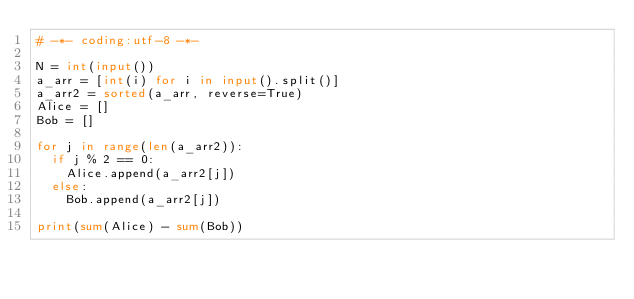Convert code to text. <code><loc_0><loc_0><loc_500><loc_500><_Python_># -*- coding:utf-8 -*-

N = int(input())
a_arr = [int(i) for i in input().split()]
a_arr2 = sorted(a_arr, reverse=True)
Alice = []
Bob = []

for j in range(len(a_arr2)):
  if j % 2 == 0:
    Alice.append(a_arr2[j])
  else:
    Bob.append(a_arr2[j])

print(sum(Alice) - sum(Bob))</code> 